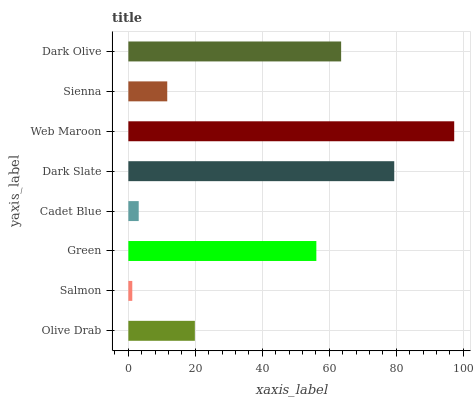Is Salmon the minimum?
Answer yes or no. Yes. Is Web Maroon the maximum?
Answer yes or no. Yes. Is Green the minimum?
Answer yes or no. No. Is Green the maximum?
Answer yes or no. No. Is Green greater than Salmon?
Answer yes or no. Yes. Is Salmon less than Green?
Answer yes or no. Yes. Is Salmon greater than Green?
Answer yes or no. No. Is Green less than Salmon?
Answer yes or no. No. Is Green the high median?
Answer yes or no. Yes. Is Olive Drab the low median?
Answer yes or no. Yes. Is Dark Olive the high median?
Answer yes or no. No. Is Salmon the low median?
Answer yes or no. No. 